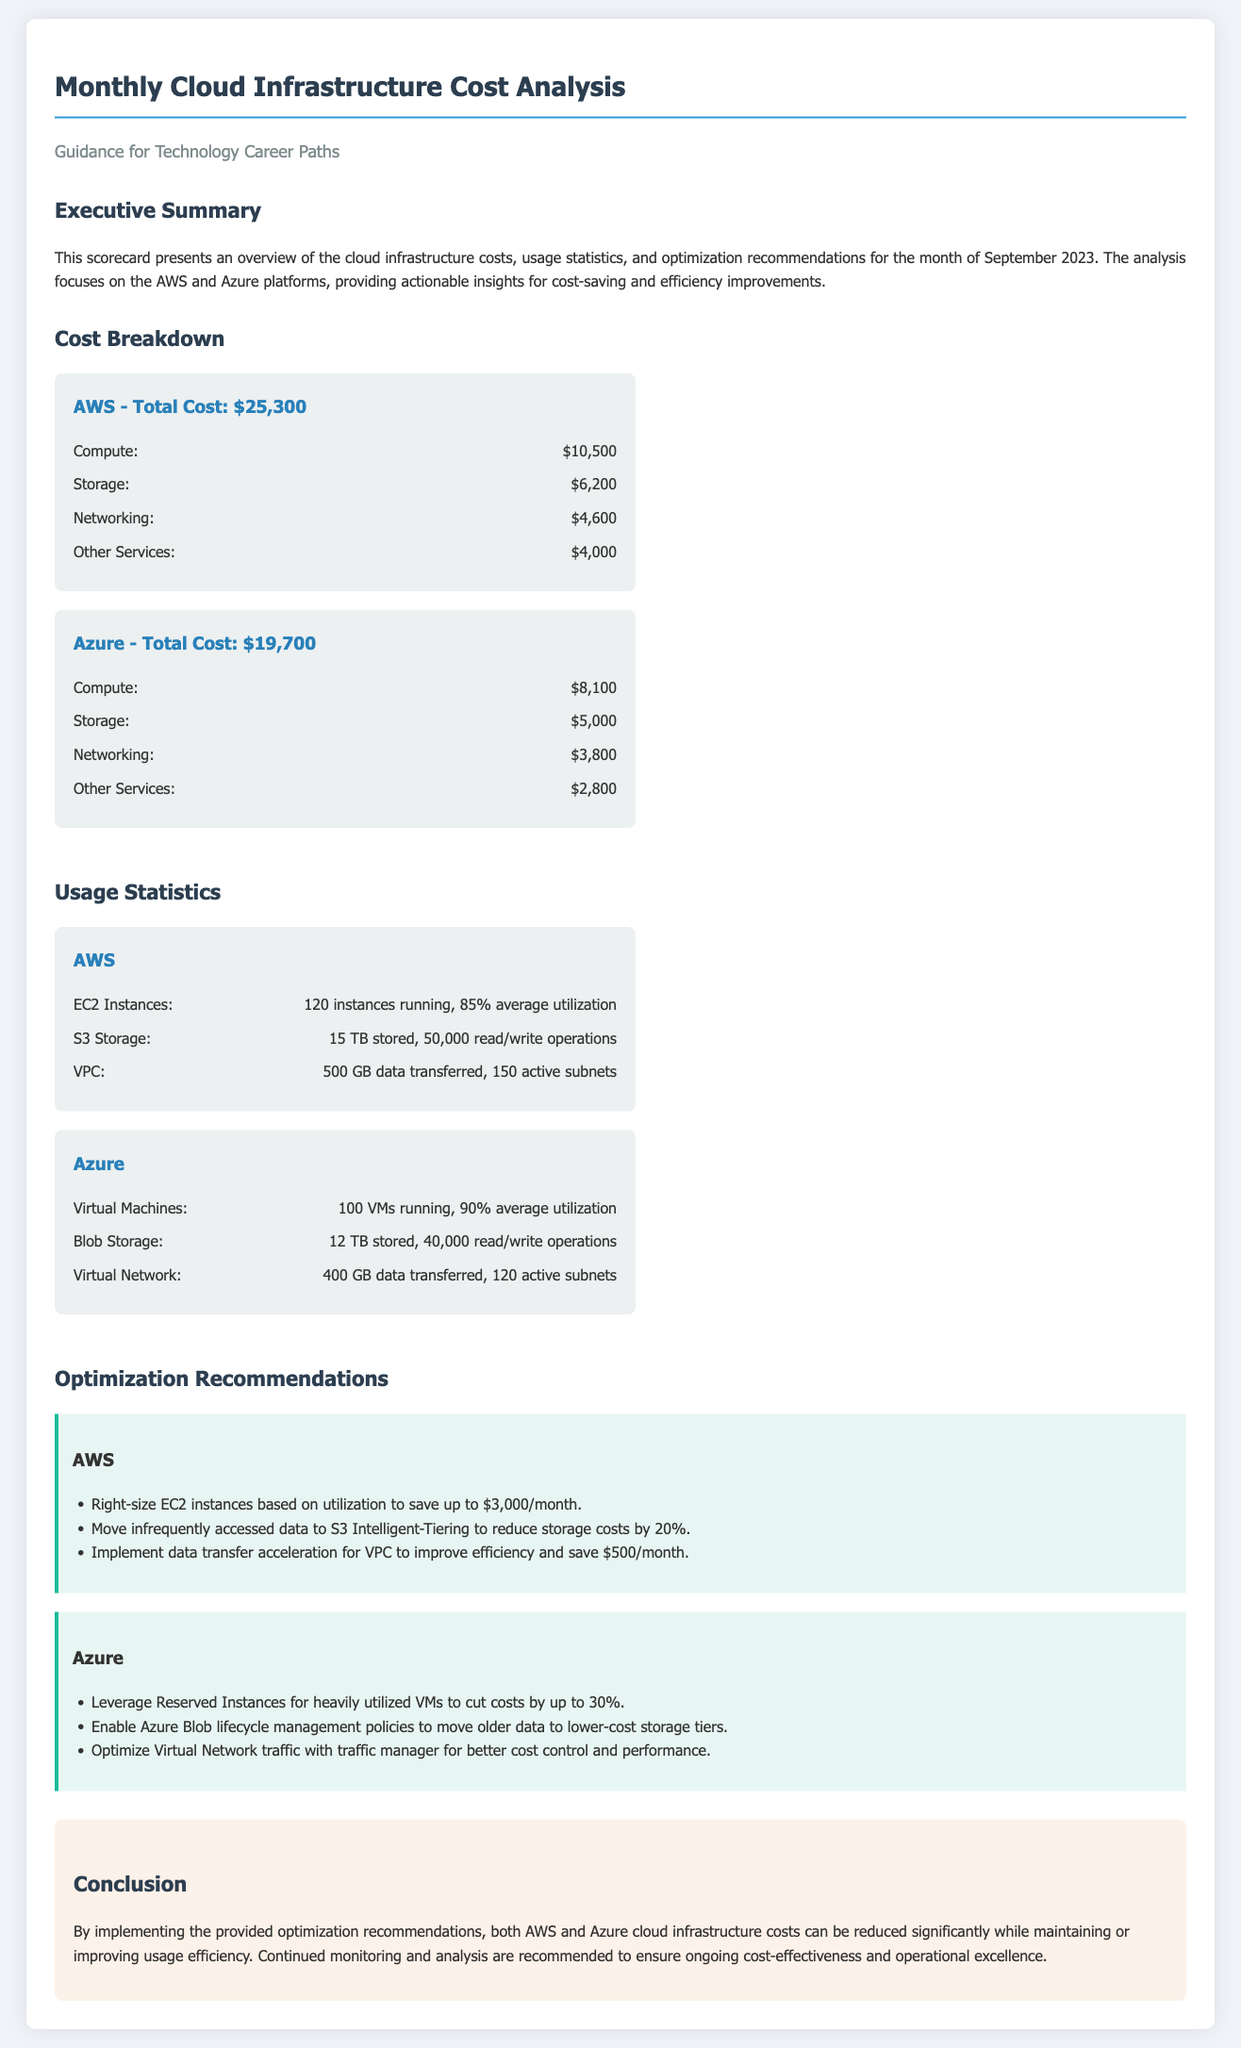What is the total cost for AWS? The total cost for AWS is stated in the cost breakdown section, which is $25,300.
Answer: $25,300 What is the average utilization of Azure Virtual Machines? The average utilization of Azure Virtual Machines is specified in the usage statistics as 90%.
Answer: 90% How much can AWS potentially save by right-sizing EC2 instances? The document includes a recommendation for AWS that states it can save up to $3,000/month by right-sizing EC2 instances.
Answer: $3,000/month What is the total cost for Azure? The total cost for Azure is presented in the cost breakdown section, which is $19,700.
Answer: $19,700 How much data is stored in AWS S3? The usage statistics indicate that there are 15 TB stored in AWS S3.
Answer: 15 TB What is one recommendation for reducing Azure costs? The document lists several recommendations, one of which is to leverage Reserved Instances for heavily utilized VMs to cut costs by up to 30%.
Answer: Leverage Reserved Instances What is the total cost for Networking on AWS? The cost breakdown shows the total cost for Networking on AWS is $4,600.
Answer: $4,600 What is the amount of data transferred in Azure Virtual Network? The usage statistics state that 400 GB of data is transferred in Azure Virtual Network.
Answer: 400 GB How many EC2 instances are running in AWS? The usage statistics for AWS indicate that there are 120 instances running.
Answer: 120 instances 